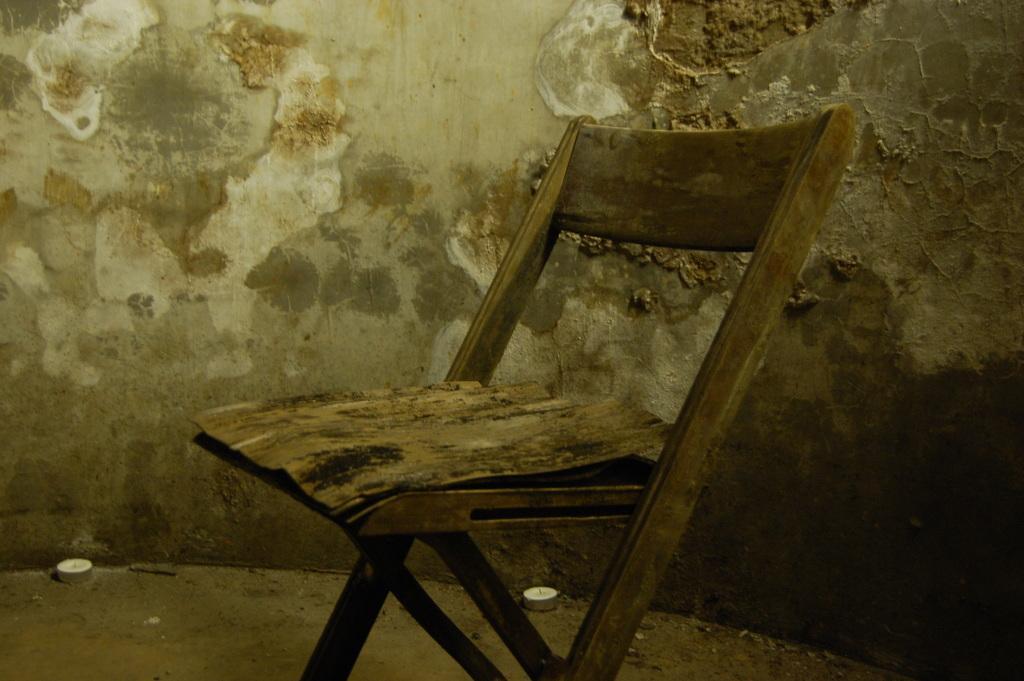Could you give a brief overview of what you see in this image? In this image I can see a chair in the front and in the background I can see the wall. I can also see two white color thing on the ground. 